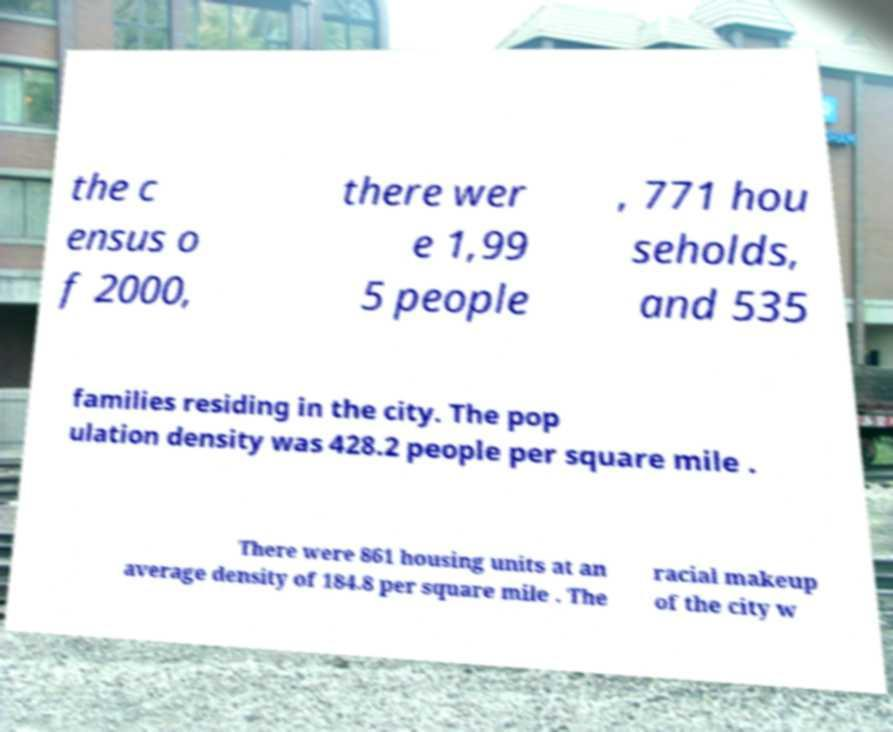There's text embedded in this image that I need extracted. Can you transcribe it verbatim? the c ensus o f 2000, there wer e 1,99 5 people , 771 hou seholds, and 535 families residing in the city. The pop ulation density was 428.2 people per square mile . There were 861 housing units at an average density of 184.8 per square mile . The racial makeup of the city w 